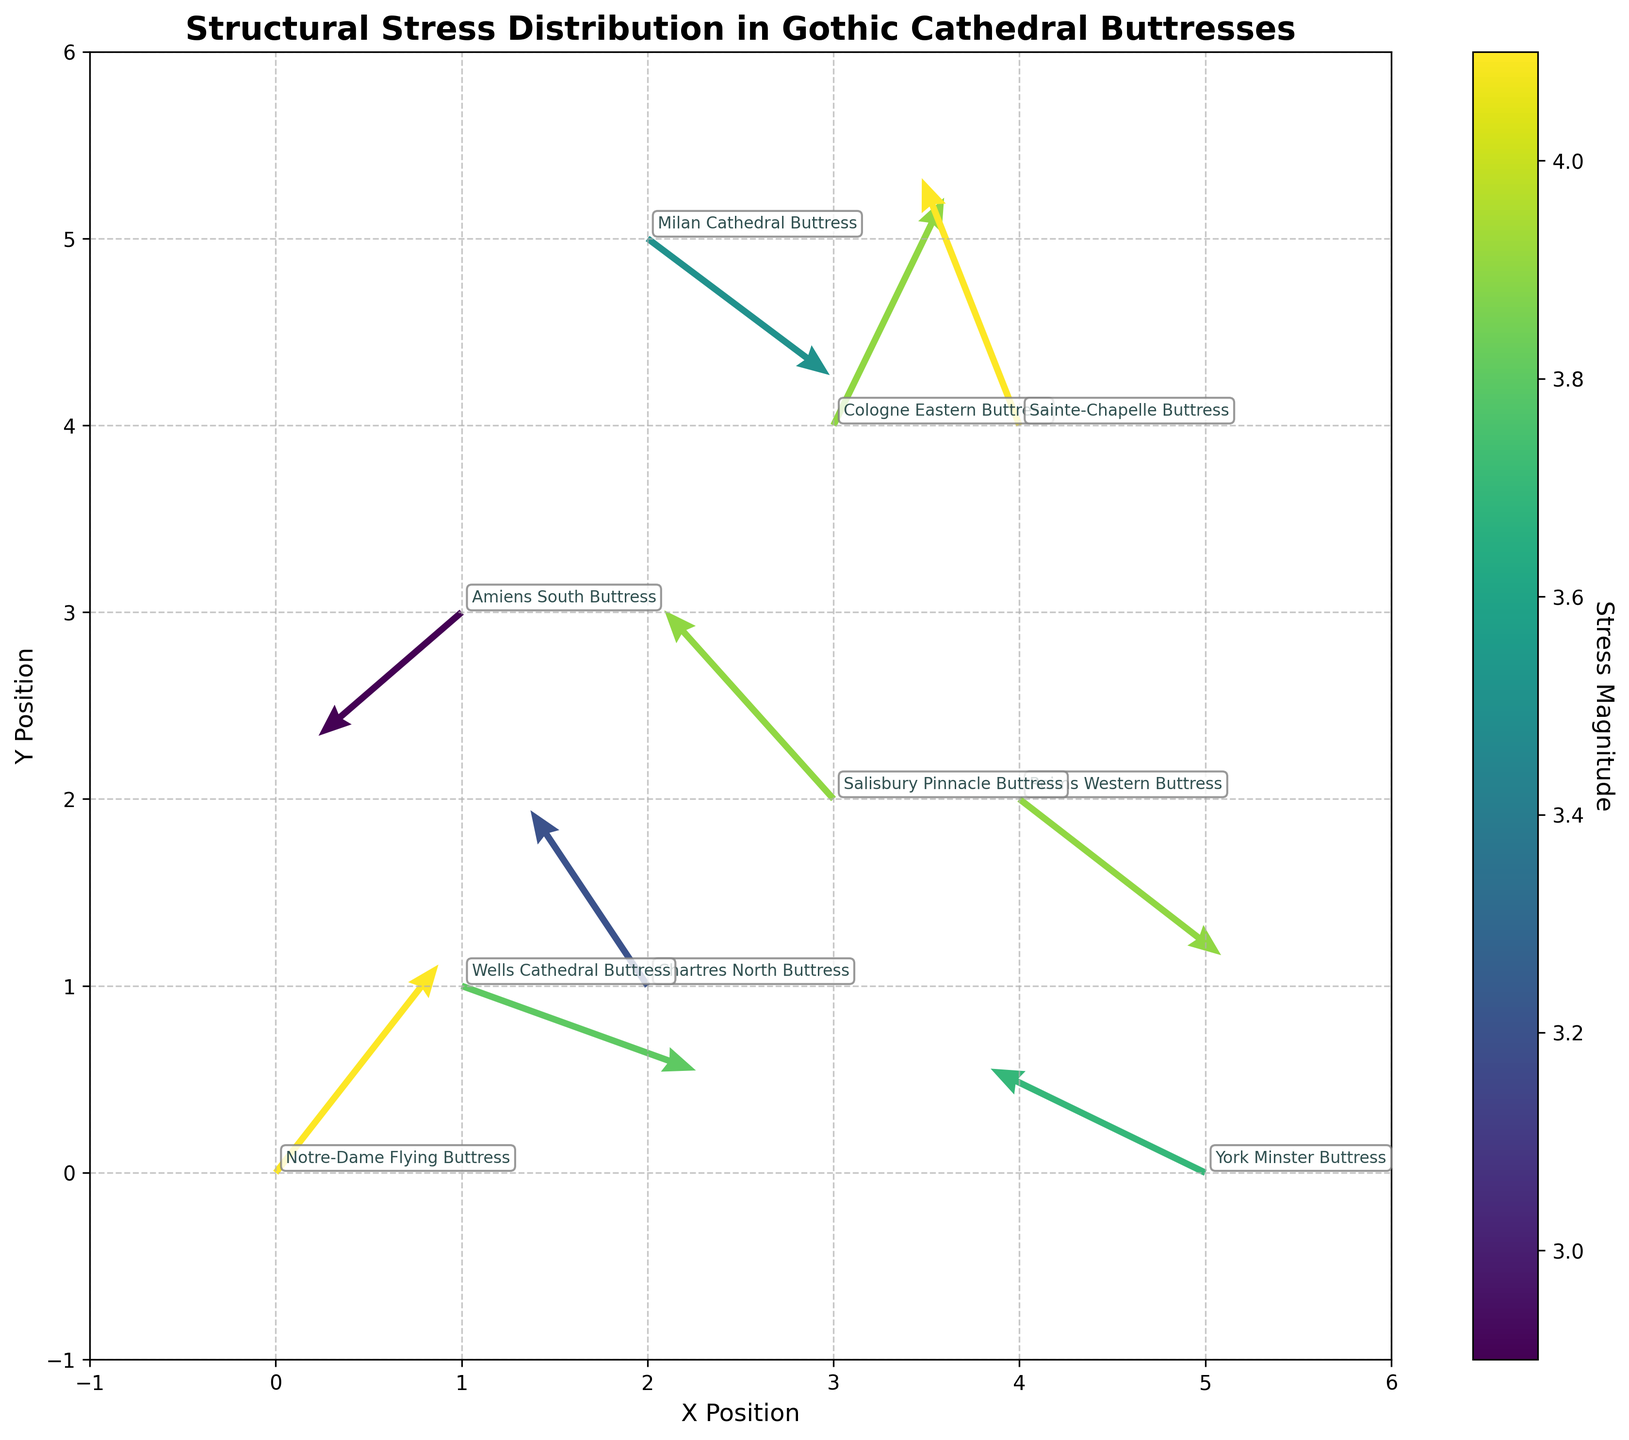What is the title of the figure? The title is usually located at the top of the figure. In this case, it is "Structural Stress Distribution in Gothic Cathedral Buttresses".
Answer: Structural Stress Distribution in Gothic Cathedral Buttresses Which axis represents the Y Position? The axis labels generally indicate what they represent. Here, the Y axis is labeled "Y Position".
Answer: Y axis How many buttresses are represented in the plot? By counting the number of annotations or data points with distinct buttress names, one can determine there are 10 different buttresses represented.
Answer: 10 Which buttress shows the largest arrow in the plot? The arrow's magnitude indicates its size. By checking the 'stress magnitude' in the color bar and arrow length, the "Notre-Dame Flying Buttress" has the highest magnitude of 4.1.
Answer: Notre-Dame Flying Buttress What is the color range used to depict stress magnitude? The color bar next to the plot shows the color range used to depict stress magnitudes, typically varying from dark to light as stress increases. In this case, it ranges from dark blue to bright yellow-green.
Answer: Dark blue to bright yellow-green Which buttress has the smallest arrow in terms of stress distribution? By comparing the lengths of the arrows and their corresponding annotated magnitude color, the "Amiens South Buttress" has the smallest stress magnitude of 2.9.
Answer: Amiens South Buttress Between "Chartres North Buttress" and "Salisbury Pinnacle Buttress", which one has a greater stress magnitude? By locating the annotations and comparing the arrows' colors and lengths, one can see that both have a stress magnitude of 3.9, so they are equal.
Answer: Equal What general direction is the stress vector pointing for "Reims Western Buttress"? By observing the direction of the arrow at the location of "Reims Western Buttress", it is pointing to the left and downward.
Answer: Left and downward Between "Sainte-Chapelle Buttress" and "Wells Cathedral Buttress", which has a vector pointing more towards the x-axis? By comparing the angles of the arrows, "Wells Cathedral Buttress" has a vector with more horizontal direction compared to "Sainte-Chapelle Buttress".
Answer: Wells Cathedral Buttress Which buttress is located at the highest Y position in the plot? By checking the Y coordinates, "Milan Cathedral Buttress" is at the Y position of 5, which is the highest.
Answer: Milan Cathedral Buttress 